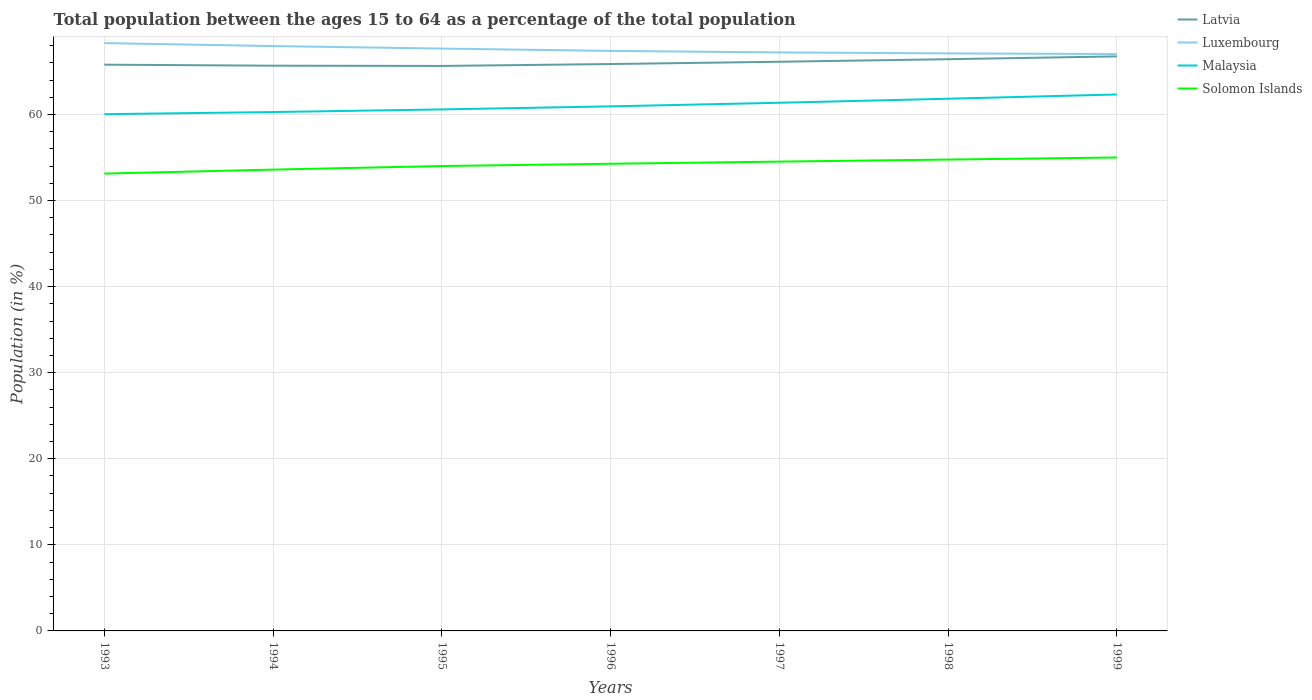How many different coloured lines are there?
Your response must be concise. 4. Across all years, what is the maximum percentage of the population ages 15 to 64 in Luxembourg?
Offer a very short reply. 67.02. What is the total percentage of the population ages 15 to 64 in Latvia in the graph?
Provide a succinct answer. -0.75. What is the difference between the highest and the second highest percentage of the population ages 15 to 64 in Latvia?
Provide a succinct answer. 1.11. What is the difference between the highest and the lowest percentage of the population ages 15 to 64 in Latvia?
Provide a short and direct response. 3. What is the difference between two consecutive major ticks on the Y-axis?
Give a very brief answer. 10. Are the values on the major ticks of Y-axis written in scientific E-notation?
Offer a terse response. No. Does the graph contain any zero values?
Your answer should be very brief. No. Where does the legend appear in the graph?
Your answer should be compact. Top right. How many legend labels are there?
Offer a very short reply. 4. What is the title of the graph?
Keep it short and to the point. Total population between the ages 15 to 64 as a percentage of the total population. Does "Guatemala" appear as one of the legend labels in the graph?
Ensure brevity in your answer.  No. What is the label or title of the X-axis?
Your response must be concise. Years. What is the label or title of the Y-axis?
Offer a very short reply. Population (in %). What is the Population (in %) of Latvia in 1993?
Your response must be concise. 65.79. What is the Population (in %) of Luxembourg in 1993?
Your answer should be compact. 68.29. What is the Population (in %) in Malaysia in 1993?
Offer a very short reply. 60.03. What is the Population (in %) in Solomon Islands in 1993?
Offer a terse response. 53.13. What is the Population (in %) in Latvia in 1994?
Your answer should be very brief. 65.67. What is the Population (in %) of Luxembourg in 1994?
Your response must be concise. 67.95. What is the Population (in %) of Malaysia in 1994?
Provide a succinct answer. 60.28. What is the Population (in %) in Solomon Islands in 1994?
Provide a short and direct response. 53.6. What is the Population (in %) in Latvia in 1995?
Your response must be concise. 65.64. What is the Population (in %) of Luxembourg in 1995?
Your response must be concise. 67.66. What is the Population (in %) in Malaysia in 1995?
Make the answer very short. 60.59. What is the Population (in %) of Solomon Islands in 1995?
Your response must be concise. 54.01. What is the Population (in %) in Latvia in 1996?
Provide a short and direct response. 65.86. What is the Population (in %) of Luxembourg in 1996?
Your answer should be very brief. 67.39. What is the Population (in %) in Malaysia in 1996?
Give a very brief answer. 60.94. What is the Population (in %) of Solomon Islands in 1996?
Make the answer very short. 54.28. What is the Population (in %) in Latvia in 1997?
Your answer should be very brief. 66.13. What is the Population (in %) of Luxembourg in 1997?
Make the answer very short. 67.21. What is the Population (in %) of Malaysia in 1997?
Provide a succinct answer. 61.36. What is the Population (in %) in Solomon Islands in 1997?
Your response must be concise. 54.52. What is the Population (in %) of Latvia in 1998?
Provide a short and direct response. 66.42. What is the Population (in %) of Luxembourg in 1998?
Ensure brevity in your answer.  67.1. What is the Population (in %) in Malaysia in 1998?
Provide a short and direct response. 61.83. What is the Population (in %) in Solomon Islands in 1998?
Offer a terse response. 54.76. What is the Population (in %) of Latvia in 1999?
Make the answer very short. 66.75. What is the Population (in %) in Luxembourg in 1999?
Give a very brief answer. 67.02. What is the Population (in %) of Malaysia in 1999?
Make the answer very short. 62.33. What is the Population (in %) of Solomon Islands in 1999?
Provide a short and direct response. 55. Across all years, what is the maximum Population (in %) of Latvia?
Offer a very short reply. 66.75. Across all years, what is the maximum Population (in %) of Luxembourg?
Your answer should be compact. 68.29. Across all years, what is the maximum Population (in %) in Malaysia?
Make the answer very short. 62.33. Across all years, what is the maximum Population (in %) of Solomon Islands?
Ensure brevity in your answer.  55. Across all years, what is the minimum Population (in %) of Latvia?
Your response must be concise. 65.64. Across all years, what is the minimum Population (in %) of Luxembourg?
Your answer should be very brief. 67.02. Across all years, what is the minimum Population (in %) of Malaysia?
Provide a succinct answer. 60.03. Across all years, what is the minimum Population (in %) of Solomon Islands?
Make the answer very short. 53.13. What is the total Population (in %) of Latvia in the graph?
Your answer should be very brief. 462.26. What is the total Population (in %) in Luxembourg in the graph?
Offer a terse response. 472.62. What is the total Population (in %) in Malaysia in the graph?
Your answer should be very brief. 427.37. What is the total Population (in %) in Solomon Islands in the graph?
Keep it short and to the point. 379.31. What is the difference between the Population (in %) of Latvia in 1993 and that in 1994?
Offer a terse response. 0.12. What is the difference between the Population (in %) in Luxembourg in 1993 and that in 1994?
Your response must be concise. 0.34. What is the difference between the Population (in %) in Malaysia in 1993 and that in 1994?
Make the answer very short. -0.25. What is the difference between the Population (in %) in Solomon Islands in 1993 and that in 1994?
Offer a very short reply. -0.46. What is the difference between the Population (in %) in Latvia in 1993 and that in 1995?
Your response must be concise. 0.15. What is the difference between the Population (in %) of Luxembourg in 1993 and that in 1995?
Offer a terse response. 0.64. What is the difference between the Population (in %) in Malaysia in 1993 and that in 1995?
Give a very brief answer. -0.55. What is the difference between the Population (in %) of Solomon Islands in 1993 and that in 1995?
Provide a succinct answer. -0.88. What is the difference between the Population (in %) of Latvia in 1993 and that in 1996?
Make the answer very short. -0.07. What is the difference between the Population (in %) of Luxembourg in 1993 and that in 1996?
Offer a very short reply. 0.91. What is the difference between the Population (in %) of Malaysia in 1993 and that in 1996?
Give a very brief answer. -0.91. What is the difference between the Population (in %) of Solomon Islands in 1993 and that in 1996?
Keep it short and to the point. -1.14. What is the difference between the Population (in %) in Latvia in 1993 and that in 1997?
Your answer should be compact. -0.34. What is the difference between the Population (in %) of Luxembourg in 1993 and that in 1997?
Your response must be concise. 1.08. What is the difference between the Population (in %) in Malaysia in 1993 and that in 1997?
Provide a succinct answer. -1.33. What is the difference between the Population (in %) of Solomon Islands in 1993 and that in 1997?
Provide a succinct answer. -1.39. What is the difference between the Population (in %) of Latvia in 1993 and that in 1998?
Provide a short and direct response. -0.64. What is the difference between the Population (in %) in Luxembourg in 1993 and that in 1998?
Your response must be concise. 1.2. What is the difference between the Population (in %) in Malaysia in 1993 and that in 1998?
Keep it short and to the point. -1.8. What is the difference between the Population (in %) of Solomon Islands in 1993 and that in 1998?
Your answer should be very brief. -1.63. What is the difference between the Population (in %) of Latvia in 1993 and that in 1999?
Keep it short and to the point. -0.96. What is the difference between the Population (in %) of Luxembourg in 1993 and that in 1999?
Your answer should be compact. 1.27. What is the difference between the Population (in %) in Malaysia in 1993 and that in 1999?
Offer a terse response. -2.29. What is the difference between the Population (in %) in Solomon Islands in 1993 and that in 1999?
Offer a very short reply. -1.87. What is the difference between the Population (in %) in Latvia in 1994 and that in 1995?
Offer a terse response. 0.03. What is the difference between the Population (in %) of Luxembourg in 1994 and that in 1995?
Your answer should be very brief. 0.29. What is the difference between the Population (in %) of Malaysia in 1994 and that in 1995?
Offer a very short reply. -0.3. What is the difference between the Population (in %) of Solomon Islands in 1994 and that in 1995?
Offer a terse response. -0.41. What is the difference between the Population (in %) in Latvia in 1994 and that in 1996?
Ensure brevity in your answer.  -0.19. What is the difference between the Population (in %) in Luxembourg in 1994 and that in 1996?
Ensure brevity in your answer.  0.56. What is the difference between the Population (in %) of Malaysia in 1994 and that in 1996?
Offer a very short reply. -0.66. What is the difference between the Population (in %) in Solomon Islands in 1994 and that in 1996?
Give a very brief answer. -0.68. What is the difference between the Population (in %) in Latvia in 1994 and that in 1997?
Make the answer very short. -0.46. What is the difference between the Population (in %) of Luxembourg in 1994 and that in 1997?
Your answer should be very brief. 0.74. What is the difference between the Population (in %) of Malaysia in 1994 and that in 1997?
Provide a succinct answer. -1.08. What is the difference between the Population (in %) of Solomon Islands in 1994 and that in 1997?
Provide a short and direct response. -0.93. What is the difference between the Population (in %) in Latvia in 1994 and that in 1998?
Your answer should be very brief. -0.75. What is the difference between the Population (in %) in Luxembourg in 1994 and that in 1998?
Your answer should be very brief. 0.85. What is the difference between the Population (in %) of Malaysia in 1994 and that in 1998?
Offer a terse response. -1.55. What is the difference between the Population (in %) in Solomon Islands in 1994 and that in 1998?
Your answer should be very brief. -1.17. What is the difference between the Population (in %) in Latvia in 1994 and that in 1999?
Your answer should be very brief. -1.08. What is the difference between the Population (in %) in Luxembourg in 1994 and that in 1999?
Make the answer very short. 0.92. What is the difference between the Population (in %) in Malaysia in 1994 and that in 1999?
Offer a terse response. -2.04. What is the difference between the Population (in %) in Solomon Islands in 1994 and that in 1999?
Offer a terse response. -1.41. What is the difference between the Population (in %) in Latvia in 1995 and that in 1996?
Provide a short and direct response. -0.22. What is the difference between the Population (in %) of Luxembourg in 1995 and that in 1996?
Offer a very short reply. 0.27. What is the difference between the Population (in %) in Malaysia in 1995 and that in 1996?
Offer a very short reply. -0.36. What is the difference between the Population (in %) of Solomon Islands in 1995 and that in 1996?
Make the answer very short. -0.27. What is the difference between the Population (in %) in Latvia in 1995 and that in 1997?
Give a very brief answer. -0.49. What is the difference between the Population (in %) in Luxembourg in 1995 and that in 1997?
Offer a very short reply. 0.45. What is the difference between the Population (in %) of Malaysia in 1995 and that in 1997?
Make the answer very short. -0.77. What is the difference between the Population (in %) of Solomon Islands in 1995 and that in 1997?
Offer a very short reply. -0.51. What is the difference between the Population (in %) of Latvia in 1995 and that in 1998?
Your answer should be very brief. -0.78. What is the difference between the Population (in %) in Luxembourg in 1995 and that in 1998?
Keep it short and to the point. 0.56. What is the difference between the Population (in %) in Malaysia in 1995 and that in 1998?
Offer a very short reply. -1.24. What is the difference between the Population (in %) in Solomon Islands in 1995 and that in 1998?
Offer a terse response. -0.75. What is the difference between the Population (in %) in Latvia in 1995 and that in 1999?
Provide a short and direct response. -1.11. What is the difference between the Population (in %) of Luxembourg in 1995 and that in 1999?
Keep it short and to the point. 0.63. What is the difference between the Population (in %) of Malaysia in 1995 and that in 1999?
Provide a succinct answer. -1.74. What is the difference between the Population (in %) in Solomon Islands in 1995 and that in 1999?
Your answer should be very brief. -0.99. What is the difference between the Population (in %) in Latvia in 1996 and that in 1997?
Offer a very short reply. -0.27. What is the difference between the Population (in %) in Luxembourg in 1996 and that in 1997?
Your answer should be very brief. 0.18. What is the difference between the Population (in %) of Malaysia in 1996 and that in 1997?
Offer a very short reply. -0.42. What is the difference between the Population (in %) in Solomon Islands in 1996 and that in 1997?
Provide a short and direct response. -0.25. What is the difference between the Population (in %) of Latvia in 1996 and that in 1998?
Ensure brevity in your answer.  -0.56. What is the difference between the Population (in %) of Luxembourg in 1996 and that in 1998?
Offer a very short reply. 0.29. What is the difference between the Population (in %) of Malaysia in 1996 and that in 1998?
Provide a short and direct response. -0.89. What is the difference between the Population (in %) of Solomon Islands in 1996 and that in 1998?
Your answer should be compact. -0.49. What is the difference between the Population (in %) of Latvia in 1996 and that in 1999?
Offer a terse response. -0.89. What is the difference between the Population (in %) in Luxembourg in 1996 and that in 1999?
Keep it short and to the point. 0.36. What is the difference between the Population (in %) of Malaysia in 1996 and that in 1999?
Ensure brevity in your answer.  -1.38. What is the difference between the Population (in %) in Solomon Islands in 1996 and that in 1999?
Ensure brevity in your answer.  -0.73. What is the difference between the Population (in %) in Latvia in 1997 and that in 1998?
Your response must be concise. -0.3. What is the difference between the Population (in %) of Luxembourg in 1997 and that in 1998?
Your answer should be very brief. 0.11. What is the difference between the Population (in %) in Malaysia in 1997 and that in 1998?
Provide a short and direct response. -0.47. What is the difference between the Population (in %) in Solomon Islands in 1997 and that in 1998?
Keep it short and to the point. -0.24. What is the difference between the Population (in %) of Latvia in 1997 and that in 1999?
Give a very brief answer. -0.63. What is the difference between the Population (in %) of Luxembourg in 1997 and that in 1999?
Keep it short and to the point. 0.19. What is the difference between the Population (in %) in Malaysia in 1997 and that in 1999?
Offer a very short reply. -0.96. What is the difference between the Population (in %) in Solomon Islands in 1997 and that in 1999?
Keep it short and to the point. -0.48. What is the difference between the Population (in %) of Latvia in 1998 and that in 1999?
Keep it short and to the point. -0.33. What is the difference between the Population (in %) in Luxembourg in 1998 and that in 1999?
Your answer should be compact. 0.07. What is the difference between the Population (in %) of Malaysia in 1998 and that in 1999?
Offer a terse response. -0.5. What is the difference between the Population (in %) in Solomon Islands in 1998 and that in 1999?
Offer a terse response. -0.24. What is the difference between the Population (in %) in Latvia in 1993 and the Population (in %) in Luxembourg in 1994?
Your response must be concise. -2.16. What is the difference between the Population (in %) in Latvia in 1993 and the Population (in %) in Malaysia in 1994?
Your answer should be very brief. 5.5. What is the difference between the Population (in %) in Latvia in 1993 and the Population (in %) in Solomon Islands in 1994?
Provide a short and direct response. 12.19. What is the difference between the Population (in %) in Luxembourg in 1993 and the Population (in %) in Malaysia in 1994?
Offer a very short reply. 8.01. What is the difference between the Population (in %) in Luxembourg in 1993 and the Population (in %) in Solomon Islands in 1994?
Offer a very short reply. 14.7. What is the difference between the Population (in %) in Malaysia in 1993 and the Population (in %) in Solomon Islands in 1994?
Your answer should be very brief. 6.44. What is the difference between the Population (in %) of Latvia in 1993 and the Population (in %) of Luxembourg in 1995?
Provide a short and direct response. -1.87. What is the difference between the Population (in %) in Latvia in 1993 and the Population (in %) in Malaysia in 1995?
Provide a succinct answer. 5.2. What is the difference between the Population (in %) of Latvia in 1993 and the Population (in %) of Solomon Islands in 1995?
Your answer should be compact. 11.78. What is the difference between the Population (in %) in Luxembourg in 1993 and the Population (in %) in Malaysia in 1995?
Your response must be concise. 7.71. What is the difference between the Population (in %) in Luxembourg in 1993 and the Population (in %) in Solomon Islands in 1995?
Provide a succinct answer. 14.28. What is the difference between the Population (in %) in Malaysia in 1993 and the Population (in %) in Solomon Islands in 1995?
Keep it short and to the point. 6.02. What is the difference between the Population (in %) of Latvia in 1993 and the Population (in %) of Luxembourg in 1996?
Your answer should be very brief. -1.6. What is the difference between the Population (in %) of Latvia in 1993 and the Population (in %) of Malaysia in 1996?
Your answer should be compact. 4.84. What is the difference between the Population (in %) of Latvia in 1993 and the Population (in %) of Solomon Islands in 1996?
Your answer should be very brief. 11.51. What is the difference between the Population (in %) of Luxembourg in 1993 and the Population (in %) of Malaysia in 1996?
Make the answer very short. 7.35. What is the difference between the Population (in %) in Luxembourg in 1993 and the Population (in %) in Solomon Islands in 1996?
Offer a terse response. 14.02. What is the difference between the Population (in %) in Malaysia in 1993 and the Population (in %) in Solomon Islands in 1996?
Provide a short and direct response. 5.76. What is the difference between the Population (in %) of Latvia in 1993 and the Population (in %) of Luxembourg in 1997?
Provide a short and direct response. -1.42. What is the difference between the Population (in %) in Latvia in 1993 and the Population (in %) in Malaysia in 1997?
Keep it short and to the point. 4.43. What is the difference between the Population (in %) of Latvia in 1993 and the Population (in %) of Solomon Islands in 1997?
Offer a terse response. 11.26. What is the difference between the Population (in %) of Luxembourg in 1993 and the Population (in %) of Malaysia in 1997?
Give a very brief answer. 6.93. What is the difference between the Population (in %) of Luxembourg in 1993 and the Population (in %) of Solomon Islands in 1997?
Offer a terse response. 13.77. What is the difference between the Population (in %) in Malaysia in 1993 and the Population (in %) in Solomon Islands in 1997?
Ensure brevity in your answer.  5.51. What is the difference between the Population (in %) in Latvia in 1993 and the Population (in %) in Luxembourg in 1998?
Provide a short and direct response. -1.31. What is the difference between the Population (in %) in Latvia in 1993 and the Population (in %) in Malaysia in 1998?
Offer a terse response. 3.96. What is the difference between the Population (in %) of Latvia in 1993 and the Population (in %) of Solomon Islands in 1998?
Offer a terse response. 11.02. What is the difference between the Population (in %) of Luxembourg in 1993 and the Population (in %) of Malaysia in 1998?
Offer a very short reply. 6.46. What is the difference between the Population (in %) of Luxembourg in 1993 and the Population (in %) of Solomon Islands in 1998?
Your answer should be compact. 13.53. What is the difference between the Population (in %) in Malaysia in 1993 and the Population (in %) in Solomon Islands in 1998?
Give a very brief answer. 5.27. What is the difference between the Population (in %) in Latvia in 1993 and the Population (in %) in Luxembourg in 1999?
Your answer should be compact. -1.24. What is the difference between the Population (in %) in Latvia in 1993 and the Population (in %) in Malaysia in 1999?
Your answer should be very brief. 3.46. What is the difference between the Population (in %) in Latvia in 1993 and the Population (in %) in Solomon Islands in 1999?
Offer a very short reply. 10.78. What is the difference between the Population (in %) of Luxembourg in 1993 and the Population (in %) of Malaysia in 1999?
Your answer should be very brief. 5.97. What is the difference between the Population (in %) of Luxembourg in 1993 and the Population (in %) of Solomon Islands in 1999?
Offer a very short reply. 13.29. What is the difference between the Population (in %) of Malaysia in 1993 and the Population (in %) of Solomon Islands in 1999?
Provide a short and direct response. 5.03. What is the difference between the Population (in %) of Latvia in 1994 and the Population (in %) of Luxembourg in 1995?
Make the answer very short. -1.99. What is the difference between the Population (in %) in Latvia in 1994 and the Population (in %) in Malaysia in 1995?
Make the answer very short. 5.08. What is the difference between the Population (in %) of Latvia in 1994 and the Population (in %) of Solomon Islands in 1995?
Provide a succinct answer. 11.66. What is the difference between the Population (in %) in Luxembourg in 1994 and the Population (in %) in Malaysia in 1995?
Make the answer very short. 7.36. What is the difference between the Population (in %) of Luxembourg in 1994 and the Population (in %) of Solomon Islands in 1995?
Offer a very short reply. 13.94. What is the difference between the Population (in %) in Malaysia in 1994 and the Population (in %) in Solomon Islands in 1995?
Your answer should be very brief. 6.27. What is the difference between the Population (in %) in Latvia in 1994 and the Population (in %) in Luxembourg in 1996?
Provide a succinct answer. -1.72. What is the difference between the Population (in %) of Latvia in 1994 and the Population (in %) of Malaysia in 1996?
Provide a succinct answer. 4.73. What is the difference between the Population (in %) of Latvia in 1994 and the Population (in %) of Solomon Islands in 1996?
Provide a succinct answer. 11.39. What is the difference between the Population (in %) in Luxembourg in 1994 and the Population (in %) in Malaysia in 1996?
Provide a succinct answer. 7. What is the difference between the Population (in %) of Luxembourg in 1994 and the Population (in %) of Solomon Islands in 1996?
Your answer should be compact. 13.67. What is the difference between the Population (in %) in Malaysia in 1994 and the Population (in %) in Solomon Islands in 1996?
Your answer should be compact. 6.01. What is the difference between the Population (in %) in Latvia in 1994 and the Population (in %) in Luxembourg in 1997?
Offer a terse response. -1.54. What is the difference between the Population (in %) in Latvia in 1994 and the Population (in %) in Malaysia in 1997?
Your response must be concise. 4.31. What is the difference between the Population (in %) in Latvia in 1994 and the Population (in %) in Solomon Islands in 1997?
Give a very brief answer. 11.14. What is the difference between the Population (in %) of Luxembourg in 1994 and the Population (in %) of Malaysia in 1997?
Your answer should be very brief. 6.59. What is the difference between the Population (in %) of Luxembourg in 1994 and the Population (in %) of Solomon Islands in 1997?
Provide a succinct answer. 13.42. What is the difference between the Population (in %) in Malaysia in 1994 and the Population (in %) in Solomon Islands in 1997?
Offer a very short reply. 5.76. What is the difference between the Population (in %) of Latvia in 1994 and the Population (in %) of Luxembourg in 1998?
Provide a succinct answer. -1.43. What is the difference between the Population (in %) of Latvia in 1994 and the Population (in %) of Malaysia in 1998?
Provide a short and direct response. 3.84. What is the difference between the Population (in %) in Latvia in 1994 and the Population (in %) in Solomon Islands in 1998?
Keep it short and to the point. 10.91. What is the difference between the Population (in %) of Luxembourg in 1994 and the Population (in %) of Malaysia in 1998?
Make the answer very short. 6.12. What is the difference between the Population (in %) of Luxembourg in 1994 and the Population (in %) of Solomon Islands in 1998?
Make the answer very short. 13.19. What is the difference between the Population (in %) of Malaysia in 1994 and the Population (in %) of Solomon Islands in 1998?
Ensure brevity in your answer.  5.52. What is the difference between the Population (in %) in Latvia in 1994 and the Population (in %) in Luxembourg in 1999?
Make the answer very short. -1.35. What is the difference between the Population (in %) of Latvia in 1994 and the Population (in %) of Malaysia in 1999?
Your answer should be very brief. 3.34. What is the difference between the Population (in %) in Latvia in 1994 and the Population (in %) in Solomon Islands in 1999?
Provide a succinct answer. 10.66. What is the difference between the Population (in %) in Luxembourg in 1994 and the Population (in %) in Malaysia in 1999?
Your answer should be very brief. 5.62. What is the difference between the Population (in %) in Luxembourg in 1994 and the Population (in %) in Solomon Islands in 1999?
Offer a terse response. 12.94. What is the difference between the Population (in %) of Malaysia in 1994 and the Population (in %) of Solomon Islands in 1999?
Make the answer very short. 5.28. What is the difference between the Population (in %) in Latvia in 1995 and the Population (in %) in Luxembourg in 1996?
Provide a short and direct response. -1.75. What is the difference between the Population (in %) of Latvia in 1995 and the Population (in %) of Malaysia in 1996?
Offer a terse response. 4.7. What is the difference between the Population (in %) in Latvia in 1995 and the Population (in %) in Solomon Islands in 1996?
Offer a very short reply. 11.36. What is the difference between the Population (in %) of Luxembourg in 1995 and the Population (in %) of Malaysia in 1996?
Your answer should be very brief. 6.71. What is the difference between the Population (in %) in Luxembourg in 1995 and the Population (in %) in Solomon Islands in 1996?
Provide a succinct answer. 13.38. What is the difference between the Population (in %) in Malaysia in 1995 and the Population (in %) in Solomon Islands in 1996?
Your answer should be very brief. 6.31. What is the difference between the Population (in %) in Latvia in 1995 and the Population (in %) in Luxembourg in 1997?
Provide a succinct answer. -1.57. What is the difference between the Population (in %) in Latvia in 1995 and the Population (in %) in Malaysia in 1997?
Give a very brief answer. 4.28. What is the difference between the Population (in %) of Latvia in 1995 and the Population (in %) of Solomon Islands in 1997?
Provide a succinct answer. 11.11. What is the difference between the Population (in %) of Luxembourg in 1995 and the Population (in %) of Malaysia in 1997?
Provide a short and direct response. 6.29. What is the difference between the Population (in %) of Luxembourg in 1995 and the Population (in %) of Solomon Islands in 1997?
Give a very brief answer. 13.13. What is the difference between the Population (in %) in Malaysia in 1995 and the Population (in %) in Solomon Islands in 1997?
Keep it short and to the point. 6.06. What is the difference between the Population (in %) in Latvia in 1995 and the Population (in %) in Luxembourg in 1998?
Provide a succinct answer. -1.46. What is the difference between the Population (in %) of Latvia in 1995 and the Population (in %) of Malaysia in 1998?
Your answer should be very brief. 3.81. What is the difference between the Population (in %) in Latvia in 1995 and the Population (in %) in Solomon Islands in 1998?
Offer a very short reply. 10.88. What is the difference between the Population (in %) in Luxembourg in 1995 and the Population (in %) in Malaysia in 1998?
Your answer should be very brief. 5.83. What is the difference between the Population (in %) of Luxembourg in 1995 and the Population (in %) of Solomon Islands in 1998?
Offer a very short reply. 12.89. What is the difference between the Population (in %) in Malaysia in 1995 and the Population (in %) in Solomon Islands in 1998?
Provide a short and direct response. 5.83. What is the difference between the Population (in %) in Latvia in 1995 and the Population (in %) in Luxembourg in 1999?
Offer a very short reply. -1.38. What is the difference between the Population (in %) in Latvia in 1995 and the Population (in %) in Malaysia in 1999?
Ensure brevity in your answer.  3.31. What is the difference between the Population (in %) of Latvia in 1995 and the Population (in %) of Solomon Islands in 1999?
Ensure brevity in your answer.  10.64. What is the difference between the Population (in %) in Luxembourg in 1995 and the Population (in %) in Malaysia in 1999?
Give a very brief answer. 5.33. What is the difference between the Population (in %) of Luxembourg in 1995 and the Population (in %) of Solomon Islands in 1999?
Your answer should be very brief. 12.65. What is the difference between the Population (in %) of Malaysia in 1995 and the Population (in %) of Solomon Islands in 1999?
Your answer should be very brief. 5.58. What is the difference between the Population (in %) of Latvia in 1996 and the Population (in %) of Luxembourg in 1997?
Your response must be concise. -1.35. What is the difference between the Population (in %) in Latvia in 1996 and the Population (in %) in Malaysia in 1997?
Provide a succinct answer. 4.5. What is the difference between the Population (in %) in Latvia in 1996 and the Population (in %) in Solomon Islands in 1997?
Keep it short and to the point. 11.33. What is the difference between the Population (in %) in Luxembourg in 1996 and the Population (in %) in Malaysia in 1997?
Provide a succinct answer. 6.03. What is the difference between the Population (in %) in Luxembourg in 1996 and the Population (in %) in Solomon Islands in 1997?
Give a very brief answer. 12.86. What is the difference between the Population (in %) in Malaysia in 1996 and the Population (in %) in Solomon Islands in 1997?
Your response must be concise. 6.42. What is the difference between the Population (in %) of Latvia in 1996 and the Population (in %) of Luxembourg in 1998?
Your response must be concise. -1.24. What is the difference between the Population (in %) of Latvia in 1996 and the Population (in %) of Malaysia in 1998?
Ensure brevity in your answer.  4.03. What is the difference between the Population (in %) in Latvia in 1996 and the Population (in %) in Solomon Islands in 1998?
Provide a succinct answer. 11.1. What is the difference between the Population (in %) of Luxembourg in 1996 and the Population (in %) of Malaysia in 1998?
Your answer should be very brief. 5.56. What is the difference between the Population (in %) in Luxembourg in 1996 and the Population (in %) in Solomon Islands in 1998?
Keep it short and to the point. 12.63. What is the difference between the Population (in %) of Malaysia in 1996 and the Population (in %) of Solomon Islands in 1998?
Offer a terse response. 6.18. What is the difference between the Population (in %) of Latvia in 1996 and the Population (in %) of Luxembourg in 1999?
Provide a short and direct response. -1.16. What is the difference between the Population (in %) in Latvia in 1996 and the Population (in %) in Malaysia in 1999?
Provide a short and direct response. 3.53. What is the difference between the Population (in %) of Latvia in 1996 and the Population (in %) of Solomon Islands in 1999?
Provide a short and direct response. 10.86. What is the difference between the Population (in %) in Luxembourg in 1996 and the Population (in %) in Malaysia in 1999?
Offer a terse response. 5.06. What is the difference between the Population (in %) in Luxembourg in 1996 and the Population (in %) in Solomon Islands in 1999?
Ensure brevity in your answer.  12.38. What is the difference between the Population (in %) of Malaysia in 1996 and the Population (in %) of Solomon Islands in 1999?
Provide a succinct answer. 5.94. What is the difference between the Population (in %) of Latvia in 1997 and the Population (in %) of Luxembourg in 1998?
Provide a succinct answer. -0.97. What is the difference between the Population (in %) of Latvia in 1997 and the Population (in %) of Malaysia in 1998?
Keep it short and to the point. 4.3. What is the difference between the Population (in %) in Latvia in 1997 and the Population (in %) in Solomon Islands in 1998?
Offer a very short reply. 11.36. What is the difference between the Population (in %) of Luxembourg in 1997 and the Population (in %) of Malaysia in 1998?
Keep it short and to the point. 5.38. What is the difference between the Population (in %) in Luxembourg in 1997 and the Population (in %) in Solomon Islands in 1998?
Offer a terse response. 12.45. What is the difference between the Population (in %) in Malaysia in 1997 and the Population (in %) in Solomon Islands in 1998?
Ensure brevity in your answer.  6.6. What is the difference between the Population (in %) in Latvia in 1997 and the Population (in %) in Luxembourg in 1999?
Make the answer very short. -0.9. What is the difference between the Population (in %) of Latvia in 1997 and the Population (in %) of Malaysia in 1999?
Provide a succinct answer. 3.8. What is the difference between the Population (in %) in Latvia in 1997 and the Population (in %) in Solomon Islands in 1999?
Your response must be concise. 11.12. What is the difference between the Population (in %) in Luxembourg in 1997 and the Population (in %) in Malaysia in 1999?
Make the answer very short. 4.88. What is the difference between the Population (in %) of Luxembourg in 1997 and the Population (in %) of Solomon Islands in 1999?
Keep it short and to the point. 12.21. What is the difference between the Population (in %) in Malaysia in 1997 and the Population (in %) in Solomon Islands in 1999?
Keep it short and to the point. 6.36. What is the difference between the Population (in %) in Latvia in 1998 and the Population (in %) in Luxembourg in 1999?
Provide a succinct answer. -0.6. What is the difference between the Population (in %) of Latvia in 1998 and the Population (in %) of Malaysia in 1999?
Ensure brevity in your answer.  4.1. What is the difference between the Population (in %) of Latvia in 1998 and the Population (in %) of Solomon Islands in 1999?
Provide a short and direct response. 11.42. What is the difference between the Population (in %) in Luxembourg in 1998 and the Population (in %) in Malaysia in 1999?
Your response must be concise. 4.77. What is the difference between the Population (in %) of Luxembourg in 1998 and the Population (in %) of Solomon Islands in 1999?
Provide a succinct answer. 12.09. What is the difference between the Population (in %) in Malaysia in 1998 and the Population (in %) in Solomon Islands in 1999?
Provide a short and direct response. 6.83. What is the average Population (in %) in Latvia per year?
Your answer should be compact. 66.04. What is the average Population (in %) of Luxembourg per year?
Offer a terse response. 67.52. What is the average Population (in %) in Malaysia per year?
Make the answer very short. 61.05. What is the average Population (in %) in Solomon Islands per year?
Provide a succinct answer. 54.19. In the year 1993, what is the difference between the Population (in %) of Latvia and Population (in %) of Luxembourg?
Provide a short and direct response. -2.51. In the year 1993, what is the difference between the Population (in %) in Latvia and Population (in %) in Malaysia?
Ensure brevity in your answer.  5.75. In the year 1993, what is the difference between the Population (in %) in Latvia and Population (in %) in Solomon Islands?
Give a very brief answer. 12.66. In the year 1993, what is the difference between the Population (in %) in Luxembourg and Population (in %) in Malaysia?
Provide a succinct answer. 8.26. In the year 1993, what is the difference between the Population (in %) of Luxembourg and Population (in %) of Solomon Islands?
Offer a terse response. 15.16. In the year 1993, what is the difference between the Population (in %) in Malaysia and Population (in %) in Solomon Islands?
Provide a short and direct response. 6.9. In the year 1994, what is the difference between the Population (in %) of Latvia and Population (in %) of Luxembourg?
Your answer should be very brief. -2.28. In the year 1994, what is the difference between the Population (in %) of Latvia and Population (in %) of Malaysia?
Offer a terse response. 5.39. In the year 1994, what is the difference between the Population (in %) of Latvia and Population (in %) of Solomon Islands?
Keep it short and to the point. 12.07. In the year 1994, what is the difference between the Population (in %) in Luxembourg and Population (in %) in Malaysia?
Your answer should be very brief. 7.66. In the year 1994, what is the difference between the Population (in %) in Luxembourg and Population (in %) in Solomon Islands?
Provide a succinct answer. 14.35. In the year 1994, what is the difference between the Population (in %) of Malaysia and Population (in %) of Solomon Islands?
Your answer should be compact. 6.69. In the year 1995, what is the difference between the Population (in %) in Latvia and Population (in %) in Luxembourg?
Keep it short and to the point. -2.02. In the year 1995, what is the difference between the Population (in %) in Latvia and Population (in %) in Malaysia?
Provide a short and direct response. 5.05. In the year 1995, what is the difference between the Population (in %) in Latvia and Population (in %) in Solomon Islands?
Offer a terse response. 11.63. In the year 1995, what is the difference between the Population (in %) in Luxembourg and Population (in %) in Malaysia?
Offer a very short reply. 7.07. In the year 1995, what is the difference between the Population (in %) in Luxembourg and Population (in %) in Solomon Islands?
Your answer should be compact. 13.65. In the year 1995, what is the difference between the Population (in %) of Malaysia and Population (in %) of Solomon Islands?
Offer a terse response. 6.58. In the year 1996, what is the difference between the Population (in %) of Latvia and Population (in %) of Luxembourg?
Ensure brevity in your answer.  -1.53. In the year 1996, what is the difference between the Population (in %) of Latvia and Population (in %) of Malaysia?
Provide a short and direct response. 4.92. In the year 1996, what is the difference between the Population (in %) in Latvia and Population (in %) in Solomon Islands?
Offer a terse response. 11.58. In the year 1996, what is the difference between the Population (in %) of Luxembourg and Population (in %) of Malaysia?
Your answer should be very brief. 6.44. In the year 1996, what is the difference between the Population (in %) in Luxembourg and Population (in %) in Solomon Islands?
Keep it short and to the point. 13.11. In the year 1996, what is the difference between the Population (in %) of Malaysia and Population (in %) of Solomon Islands?
Give a very brief answer. 6.67. In the year 1997, what is the difference between the Population (in %) of Latvia and Population (in %) of Luxembourg?
Offer a terse response. -1.08. In the year 1997, what is the difference between the Population (in %) of Latvia and Population (in %) of Malaysia?
Provide a short and direct response. 4.76. In the year 1997, what is the difference between the Population (in %) of Latvia and Population (in %) of Solomon Islands?
Make the answer very short. 11.6. In the year 1997, what is the difference between the Population (in %) in Luxembourg and Population (in %) in Malaysia?
Give a very brief answer. 5.85. In the year 1997, what is the difference between the Population (in %) of Luxembourg and Population (in %) of Solomon Islands?
Offer a very short reply. 12.68. In the year 1997, what is the difference between the Population (in %) of Malaysia and Population (in %) of Solomon Islands?
Provide a succinct answer. 6.84. In the year 1998, what is the difference between the Population (in %) in Latvia and Population (in %) in Luxembourg?
Your response must be concise. -0.67. In the year 1998, what is the difference between the Population (in %) of Latvia and Population (in %) of Malaysia?
Provide a short and direct response. 4.59. In the year 1998, what is the difference between the Population (in %) of Latvia and Population (in %) of Solomon Islands?
Your answer should be very brief. 11.66. In the year 1998, what is the difference between the Population (in %) in Luxembourg and Population (in %) in Malaysia?
Your answer should be very brief. 5.27. In the year 1998, what is the difference between the Population (in %) in Luxembourg and Population (in %) in Solomon Islands?
Ensure brevity in your answer.  12.33. In the year 1998, what is the difference between the Population (in %) of Malaysia and Population (in %) of Solomon Islands?
Your response must be concise. 7.07. In the year 1999, what is the difference between the Population (in %) in Latvia and Population (in %) in Luxembourg?
Provide a short and direct response. -0.27. In the year 1999, what is the difference between the Population (in %) in Latvia and Population (in %) in Malaysia?
Offer a terse response. 4.43. In the year 1999, what is the difference between the Population (in %) in Latvia and Population (in %) in Solomon Islands?
Your response must be concise. 11.75. In the year 1999, what is the difference between the Population (in %) in Luxembourg and Population (in %) in Malaysia?
Your answer should be compact. 4.7. In the year 1999, what is the difference between the Population (in %) of Luxembourg and Population (in %) of Solomon Islands?
Offer a terse response. 12.02. In the year 1999, what is the difference between the Population (in %) of Malaysia and Population (in %) of Solomon Islands?
Keep it short and to the point. 7.32. What is the ratio of the Population (in %) in Luxembourg in 1993 to that in 1994?
Your answer should be compact. 1.01. What is the ratio of the Population (in %) of Solomon Islands in 1993 to that in 1994?
Provide a succinct answer. 0.99. What is the ratio of the Population (in %) in Latvia in 1993 to that in 1995?
Give a very brief answer. 1. What is the ratio of the Population (in %) of Luxembourg in 1993 to that in 1995?
Ensure brevity in your answer.  1.01. What is the ratio of the Population (in %) in Malaysia in 1993 to that in 1995?
Offer a terse response. 0.99. What is the ratio of the Population (in %) in Solomon Islands in 1993 to that in 1995?
Your answer should be very brief. 0.98. What is the ratio of the Population (in %) in Luxembourg in 1993 to that in 1996?
Give a very brief answer. 1.01. What is the ratio of the Population (in %) of Malaysia in 1993 to that in 1996?
Offer a terse response. 0.99. What is the ratio of the Population (in %) in Solomon Islands in 1993 to that in 1996?
Keep it short and to the point. 0.98. What is the ratio of the Population (in %) of Luxembourg in 1993 to that in 1997?
Ensure brevity in your answer.  1.02. What is the ratio of the Population (in %) in Malaysia in 1993 to that in 1997?
Offer a terse response. 0.98. What is the ratio of the Population (in %) in Solomon Islands in 1993 to that in 1997?
Your answer should be compact. 0.97. What is the ratio of the Population (in %) in Luxembourg in 1993 to that in 1998?
Your response must be concise. 1.02. What is the ratio of the Population (in %) of Malaysia in 1993 to that in 1998?
Provide a succinct answer. 0.97. What is the ratio of the Population (in %) in Solomon Islands in 1993 to that in 1998?
Give a very brief answer. 0.97. What is the ratio of the Population (in %) of Latvia in 1993 to that in 1999?
Give a very brief answer. 0.99. What is the ratio of the Population (in %) of Luxembourg in 1993 to that in 1999?
Your answer should be very brief. 1.02. What is the ratio of the Population (in %) of Malaysia in 1993 to that in 1999?
Provide a succinct answer. 0.96. What is the ratio of the Population (in %) of Solomon Islands in 1993 to that in 1999?
Make the answer very short. 0.97. What is the ratio of the Population (in %) in Luxembourg in 1994 to that in 1995?
Offer a very short reply. 1. What is the ratio of the Population (in %) of Malaysia in 1994 to that in 1995?
Keep it short and to the point. 0.99. What is the ratio of the Population (in %) in Latvia in 1994 to that in 1996?
Keep it short and to the point. 1. What is the ratio of the Population (in %) in Luxembourg in 1994 to that in 1996?
Offer a very short reply. 1.01. What is the ratio of the Population (in %) of Solomon Islands in 1994 to that in 1996?
Ensure brevity in your answer.  0.99. What is the ratio of the Population (in %) in Latvia in 1994 to that in 1997?
Provide a short and direct response. 0.99. What is the ratio of the Population (in %) of Malaysia in 1994 to that in 1997?
Ensure brevity in your answer.  0.98. What is the ratio of the Population (in %) in Luxembourg in 1994 to that in 1998?
Your response must be concise. 1.01. What is the ratio of the Population (in %) of Malaysia in 1994 to that in 1998?
Provide a succinct answer. 0.97. What is the ratio of the Population (in %) in Solomon Islands in 1994 to that in 1998?
Your answer should be very brief. 0.98. What is the ratio of the Population (in %) in Latvia in 1994 to that in 1999?
Provide a succinct answer. 0.98. What is the ratio of the Population (in %) in Luxembourg in 1994 to that in 1999?
Your response must be concise. 1.01. What is the ratio of the Population (in %) of Malaysia in 1994 to that in 1999?
Your answer should be very brief. 0.97. What is the ratio of the Population (in %) in Solomon Islands in 1994 to that in 1999?
Give a very brief answer. 0.97. What is the ratio of the Population (in %) of Solomon Islands in 1995 to that in 1996?
Offer a very short reply. 1. What is the ratio of the Population (in %) in Luxembourg in 1995 to that in 1997?
Keep it short and to the point. 1.01. What is the ratio of the Population (in %) in Malaysia in 1995 to that in 1997?
Ensure brevity in your answer.  0.99. What is the ratio of the Population (in %) of Solomon Islands in 1995 to that in 1997?
Provide a short and direct response. 0.99. What is the ratio of the Population (in %) in Latvia in 1995 to that in 1998?
Ensure brevity in your answer.  0.99. What is the ratio of the Population (in %) in Luxembourg in 1995 to that in 1998?
Your answer should be very brief. 1.01. What is the ratio of the Population (in %) of Malaysia in 1995 to that in 1998?
Your answer should be compact. 0.98. What is the ratio of the Population (in %) of Solomon Islands in 1995 to that in 1998?
Make the answer very short. 0.99. What is the ratio of the Population (in %) in Latvia in 1995 to that in 1999?
Your response must be concise. 0.98. What is the ratio of the Population (in %) of Luxembourg in 1995 to that in 1999?
Provide a short and direct response. 1.01. What is the ratio of the Population (in %) in Malaysia in 1995 to that in 1999?
Your answer should be compact. 0.97. What is the ratio of the Population (in %) in Solomon Islands in 1995 to that in 1999?
Your answer should be compact. 0.98. What is the ratio of the Population (in %) in Luxembourg in 1996 to that in 1997?
Give a very brief answer. 1. What is the ratio of the Population (in %) in Malaysia in 1996 to that in 1997?
Offer a very short reply. 0.99. What is the ratio of the Population (in %) of Malaysia in 1996 to that in 1998?
Ensure brevity in your answer.  0.99. What is the ratio of the Population (in %) of Solomon Islands in 1996 to that in 1998?
Give a very brief answer. 0.99. What is the ratio of the Population (in %) of Latvia in 1996 to that in 1999?
Provide a short and direct response. 0.99. What is the ratio of the Population (in %) in Luxembourg in 1996 to that in 1999?
Provide a short and direct response. 1.01. What is the ratio of the Population (in %) in Malaysia in 1996 to that in 1999?
Provide a succinct answer. 0.98. What is the ratio of the Population (in %) in Latvia in 1997 to that in 1999?
Give a very brief answer. 0.99. What is the ratio of the Population (in %) in Malaysia in 1997 to that in 1999?
Provide a short and direct response. 0.98. What is the ratio of the Population (in %) of Solomon Islands in 1997 to that in 1999?
Make the answer very short. 0.99. What is the ratio of the Population (in %) in Latvia in 1998 to that in 1999?
Provide a succinct answer. 1. What is the ratio of the Population (in %) in Malaysia in 1998 to that in 1999?
Provide a succinct answer. 0.99. What is the ratio of the Population (in %) in Solomon Islands in 1998 to that in 1999?
Provide a short and direct response. 1. What is the difference between the highest and the second highest Population (in %) in Latvia?
Give a very brief answer. 0.33. What is the difference between the highest and the second highest Population (in %) in Luxembourg?
Keep it short and to the point. 0.34. What is the difference between the highest and the second highest Population (in %) in Malaysia?
Give a very brief answer. 0.5. What is the difference between the highest and the second highest Population (in %) of Solomon Islands?
Give a very brief answer. 0.24. What is the difference between the highest and the lowest Population (in %) in Latvia?
Give a very brief answer. 1.11. What is the difference between the highest and the lowest Population (in %) in Luxembourg?
Offer a very short reply. 1.27. What is the difference between the highest and the lowest Population (in %) in Malaysia?
Give a very brief answer. 2.29. What is the difference between the highest and the lowest Population (in %) of Solomon Islands?
Your answer should be very brief. 1.87. 